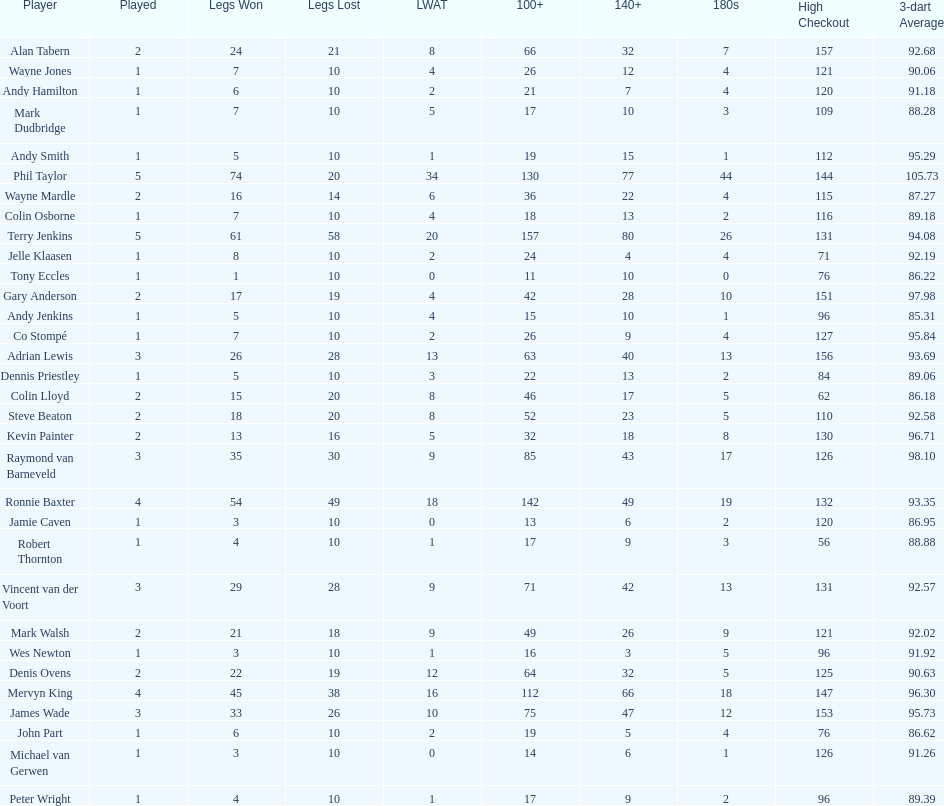Would you be able to parse every entry in this table? {'header': ['Player', 'Played', 'Legs Won', 'Legs Lost', 'LWAT', '100+', '140+', '180s', 'High Checkout', '3-dart Average'], 'rows': [['Alan Tabern', '2', '24', '21', '8', '66', '32', '7', '157', '92.68'], ['Wayne Jones', '1', '7', '10', '4', '26', '12', '4', '121', '90.06'], ['Andy Hamilton', '1', '6', '10', '2', '21', '7', '4', '120', '91.18'], ['Mark Dudbridge', '1', '7', '10', '5', '17', '10', '3', '109', '88.28'], ['Andy Smith', '1', '5', '10', '1', '19', '15', '1', '112', '95.29'], ['Phil Taylor', '5', '74', '20', '34', '130', '77', '44', '144', '105.73'], ['Wayne Mardle', '2', '16', '14', '6', '36', '22', '4', '115', '87.27'], ['Colin Osborne', '1', '7', '10', '4', '18', '13', '2', '116', '89.18'], ['Terry Jenkins', '5', '61', '58', '20', '157', '80', '26', '131', '94.08'], ['Jelle Klaasen', '1', '8', '10', '2', '24', '4', '4', '71', '92.19'], ['Tony Eccles', '1', '1', '10', '0', '11', '10', '0', '76', '86.22'], ['Gary Anderson', '2', '17', '19', '4', '42', '28', '10', '151', '97.98'], ['Andy Jenkins', '1', '5', '10', '4', '15', '10', '1', '96', '85.31'], ['Co Stompé', '1', '7', '10', '2', '26', '9', '4', '127', '95.84'], ['Adrian Lewis', '3', '26', '28', '13', '63', '40', '13', '156', '93.69'], ['Dennis Priestley', '1', '5', '10', '3', '22', '13', '2', '84', '89.06'], ['Colin Lloyd', '2', '15', '20', '8', '46', '17', '5', '62', '86.18'], ['Steve Beaton', '2', '18', '20', '8', '52', '23', '5', '110', '92.58'], ['Kevin Painter', '2', '13', '16', '5', '32', '18', '8', '130', '96.71'], ['Raymond van Barneveld', '3', '35', '30', '9', '85', '43', '17', '126', '98.10'], ['Ronnie Baxter', '4', '54', '49', '18', '142', '49', '19', '132', '93.35'], ['Jamie Caven', '1', '3', '10', '0', '13', '6', '2', '120', '86.95'], ['Robert Thornton', '1', '4', '10', '1', '17', '9', '3', '56', '88.88'], ['Vincent van der Voort', '3', '29', '28', '9', '71', '42', '13', '131', '92.57'], ['Mark Walsh', '2', '21', '18', '9', '49', '26', '9', '121', '92.02'], ['Wes Newton', '1', '3', '10', '1', '16', '3', '5', '96', '91.92'], ['Denis Ovens', '2', '22', '19', '12', '64', '32', '5', '125', '90.63'], ['Mervyn King', '4', '45', '38', '16', '112', '66', '18', '147', '96.30'], ['James Wade', '3', '33', '26', '10', '75', '47', '12', '153', '95.73'], ['John Part', '1', '6', '10', '2', '19', '5', '4', '76', '86.62'], ['Michael van Gerwen', '1', '3', '10', '0', '14', '6', '1', '126', '91.26'], ['Peter Wright', '1', '4', '10', '1', '17', '9', '2', '96', '89.39']]} Was andy smith or kevin painter's 3-dart average 96.71? Kevin Painter. 